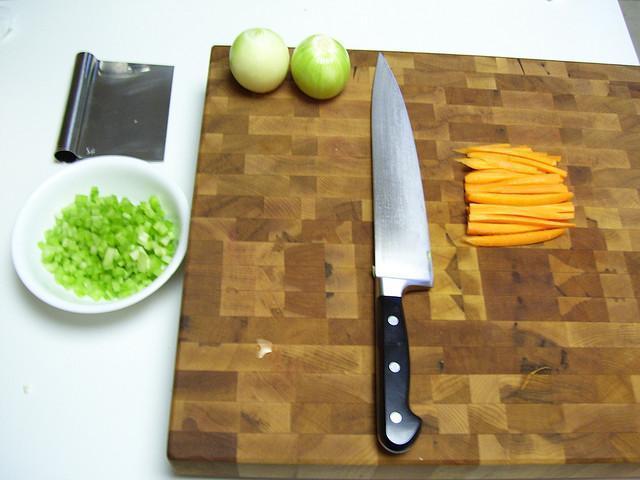How many apples are in the picture?
Give a very brief answer. 2. How many people are wearing glasses?
Give a very brief answer. 0. 